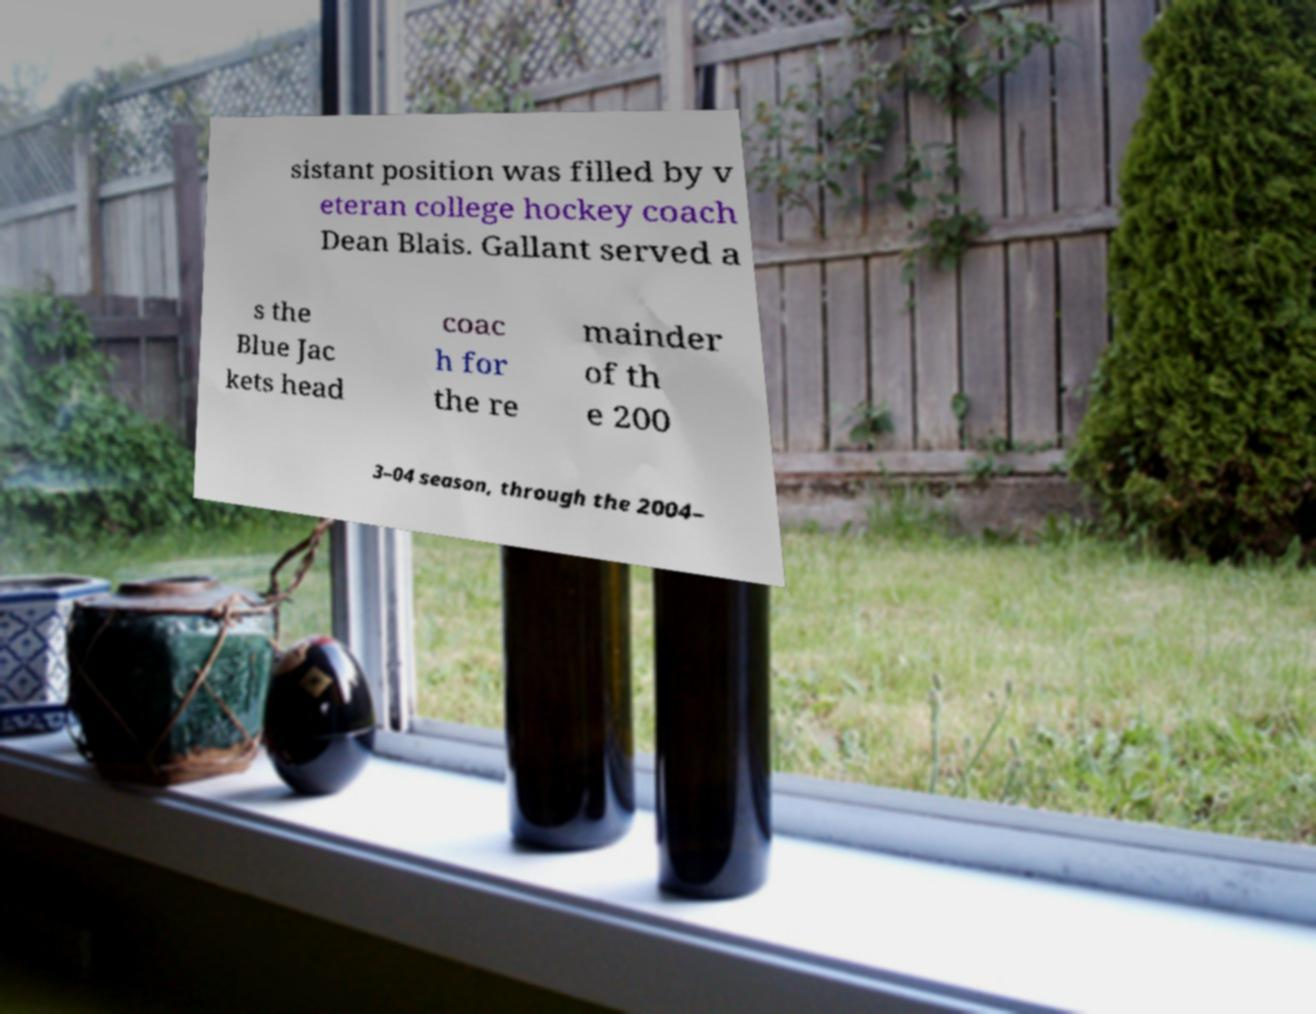Please read and relay the text visible in this image. What does it say? sistant position was filled by v eteran college hockey coach Dean Blais. Gallant served a s the Blue Jac kets head coac h for the re mainder of th e 200 3–04 season, through the 2004– 